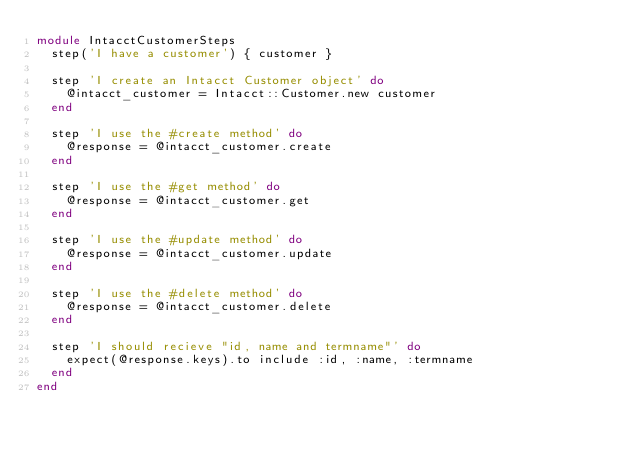Convert code to text. <code><loc_0><loc_0><loc_500><loc_500><_Ruby_>module IntacctCustomerSteps
  step('I have a customer') { customer }

  step 'I create an Intacct Customer object' do
    @intacct_customer = Intacct::Customer.new customer
  end

  step 'I use the #create method' do
    @response = @intacct_customer.create
  end

  step 'I use the #get method' do
    @response = @intacct_customer.get
  end

  step 'I use the #update method' do
    @response = @intacct_customer.update
  end

  step 'I use the #delete method' do
    @response = @intacct_customer.delete
  end

  step 'I should recieve "id, name and termname"' do
    expect(@response.keys).to include :id, :name, :termname
  end
end
</code> 